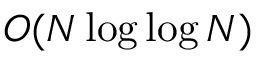Convert formula to latex. <formula><loc_0><loc_0><loc_500><loc_500>O ( N \log \log N )</formula> 